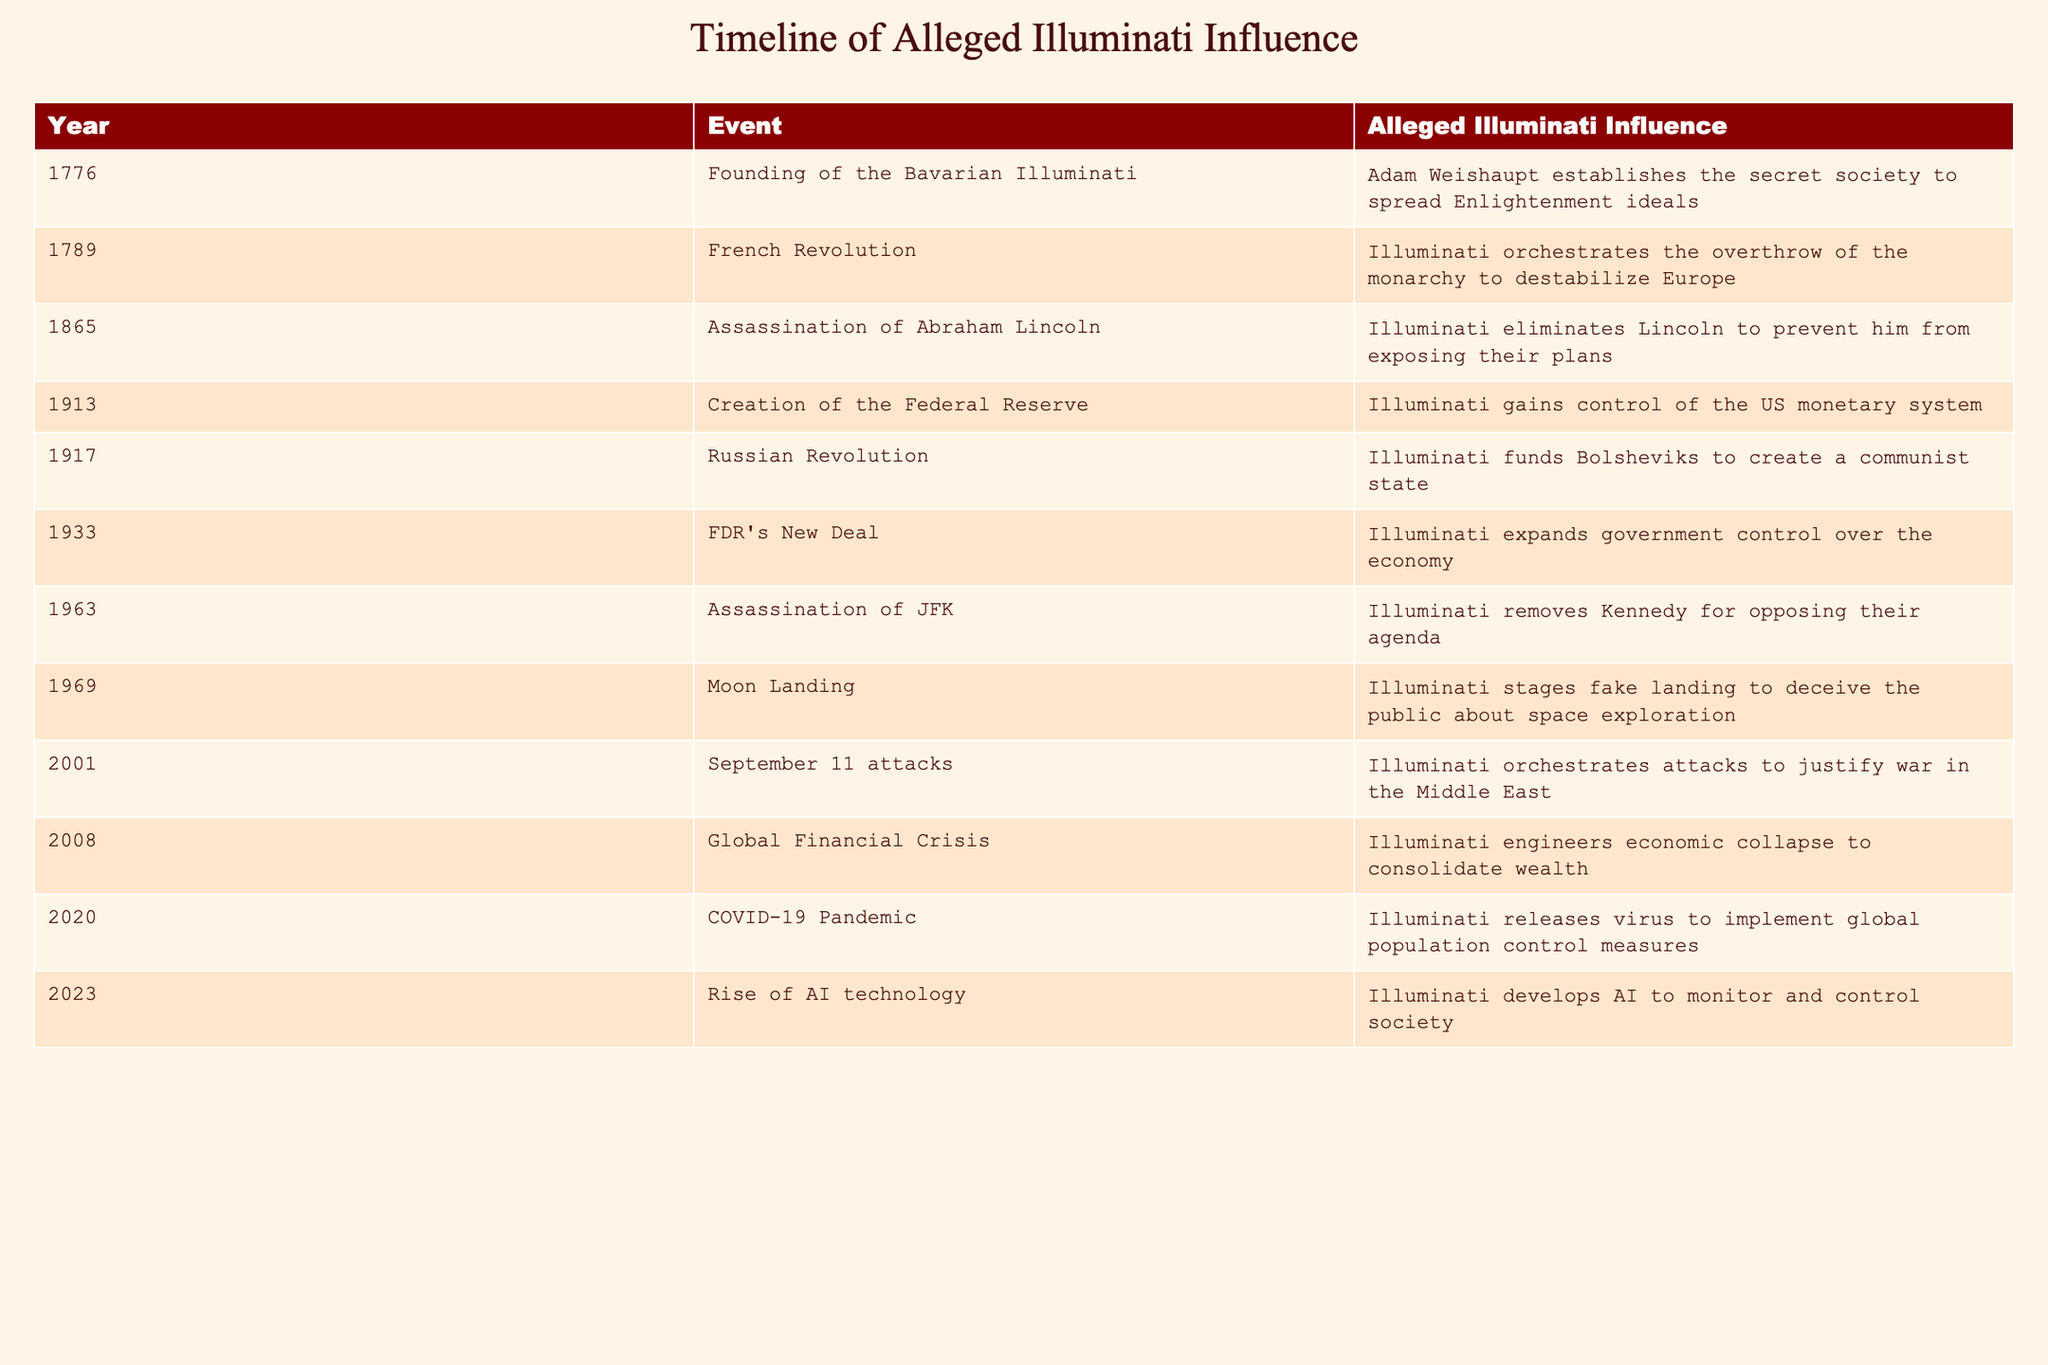What year did the Bavarian Illuminati get founded? The table clearly shows the founding year of the Bavarian Illuminati in the first row, which is 1776.
Answer: 1776 Which event is associated with the alleged Illuminati influence in 1963? The table indicates that the event associated with the alleged Illuminati influence in 1963 is the assassination of JFK.
Answer: Assassination of JFK Count the number of events listed in the table that occurred before 1900. There are four events before 1900, which include 1776 (Founding of the Bavarian Illuminati), 1789 (French Revolution), 1865 (Assassination of Abraham Lincoln), and 1913 (Creation of the Federal Reserve).
Answer: 4 True or False: The Illuminati was alleged to be involved in the creation of the Federal Reserve. The table explicitly states that in 1913, the creation of the Federal Reserve is associated with the Illuminati gaining control of the US monetary system, which confirms that the statement is true.
Answer: True What is the span of years between the French Revolution and the Russian Revolution? The French Revolution occurred in 1789 and the Russian Revolution in 1917. To find the span, we subtract 1789 from 1917, resulting in 128 years between these events.
Answer: 128 years Identify the two events that occurred in the 21st century and summarize their alleged Illuminati influence. The two 21st-century events are the September 11 attacks in 2001 and the COVID-19 pandemic in 2020. The table indicates that the September 11 attacks were orchestrated to justify war in the Middle East, while the COVID-19 pandemic was linked to global population control measures.
Answer: September 11 attacks (justified war) and COVID-19 pandemic (population control) How many times is the term "Illuminati" mentioned in relation to events occurring in the 20th century? The term "Illuminati" appears in connection with five events in the 20th century: the creation of the Federal Reserve (1913), the Russian Revolution (1917), FDR's New Deal (1933), the assassination of JFK (1963), and the moon landing (1969). Therefore, it is mentioned five times.
Answer: 5 What percentage of the events listed involve assassinations? The table lists a total of 12 events, out of which 3 are related to assassination (Assassination of Abraham Lincoln in 1865, Assassination of JFK in 1963, and the implication around Illuminati influence in the creation of the police state). To find the percentage, we calculate (3/12)*100 = 25%.
Answer: 25% Summarize the allegations associated with the year 2008 in one sentence. In 2008, the table states that the Global Financial Crisis was alleged to have been engineered by the Illuminati to consolidate wealth.
Answer: Illuminati engineered economic crisis for wealth consolidation 